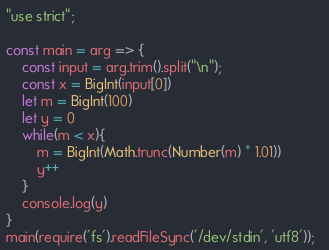Convert code to text. <code><loc_0><loc_0><loc_500><loc_500><_JavaScript_>"use strict";

const main = arg => {
    const input = arg.trim().split("\n");
    const x = BigInt(input[0])
    let m = BigInt(100)
    let y = 0
    while(m < x){
        m = BigInt(Math.trunc(Number(m) * 1.01))
        y++
    }
    console.log(y)
}
main(require('fs').readFileSync('/dev/stdin', 'utf8'));  </code> 